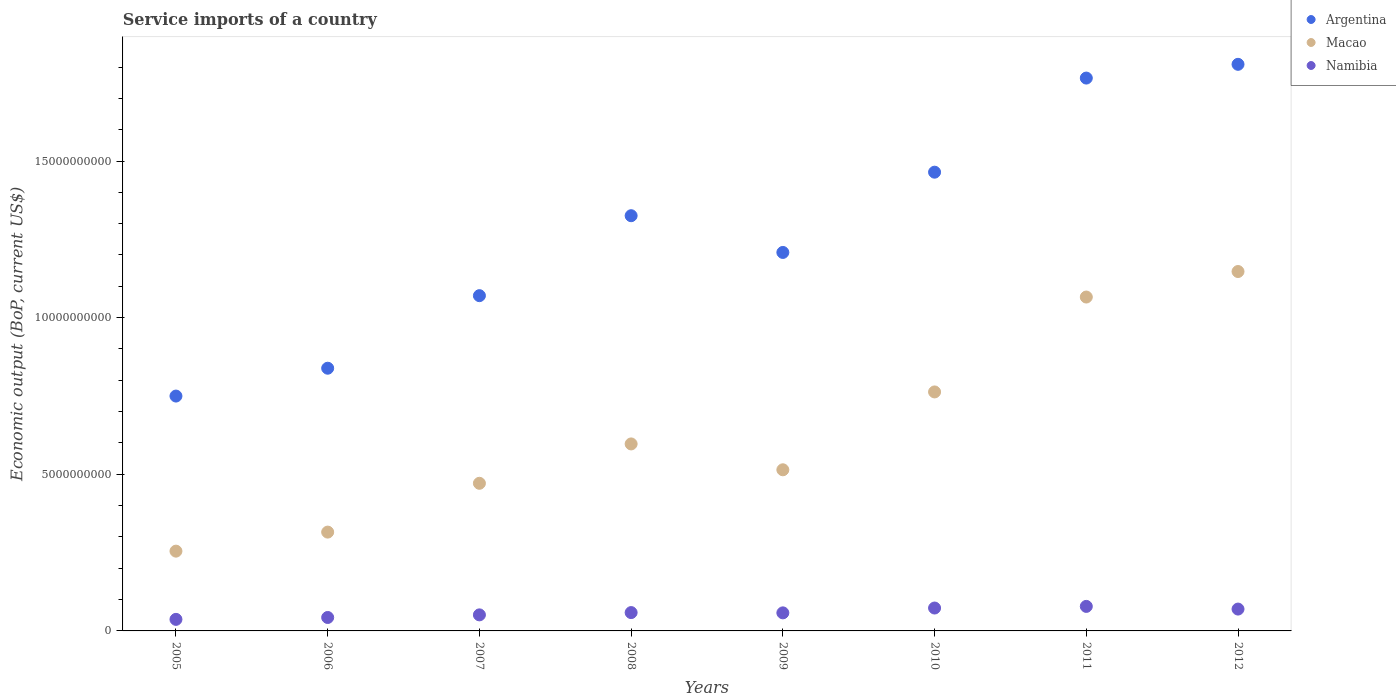Is the number of dotlines equal to the number of legend labels?
Your answer should be very brief. Yes. What is the service imports in Argentina in 2011?
Your response must be concise. 1.76e+1. Across all years, what is the maximum service imports in Argentina?
Your answer should be very brief. 1.81e+1. Across all years, what is the minimum service imports in Namibia?
Provide a short and direct response. 3.69e+08. What is the total service imports in Macao in the graph?
Ensure brevity in your answer.  5.13e+1. What is the difference between the service imports in Macao in 2009 and that in 2010?
Offer a very short reply. -2.49e+09. What is the difference between the service imports in Namibia in 2012 and the service imports in Macao in 2009?
Make the answer very short. -4.45e+09. What is the average service imports in Macao per year?
Offer a terse response. 6.41e+09. In the year 2010, what is the difference between the service imports in Argentina and service imports in Macao?
Your answer should be very brief. 7.01e+09. In how many years, is the service imports in Macao greater than 17000000000 US$?
Your answer should be very brief. 0. What is the ratio of the service imports in Namibia in 2011 to that in 2012?
Your answer should be very brief. 1.12. Is the difference between the service imports in Argentina in 2005 and 2008 greater than the difference between the service imports in Macao in 2005 and 2008?
Your answer should be very brief. No. What is the difference between the highest and the second highest service imports in Argentina?
Provide a succinct answer. 4.39e+08. What is the difference between the highest and the lowest service imports in Argentina?
Your response must be concise. 1.06e+1. Does the service imports in Macao monotonically increase over the years?
Make the answer very short. No. Is the service imports in Macao strictly less than the service imports in Namibia over the years?
Your answer should be compact. No. How many dotlines are there?
Keep it short and to the point. 3. How many years are there in the graph?
Provide a succinct answer. 8. What is the difference between two consecutive major ticks on the Y-axis?
Your answer should be very brief. 5.00e+09. Are the values on the major ticks of Y-axis written in scientific E-notation?
Offer a very short reply. No. Does the graph contain any zero values?
Make the answer very short. No. What is the title of the graph?
Provide a short and direct response. Service imports of a country. What is the label or title of the Y-axis?
Ensure brevity in your answer.  Economic output (BoP, current US$). What is the Economic output (BoP, current US$) of Argentina in 2005?
Your response must be concise. 7.50e+09. What is the Economic output (BoP, current US$) in Macao in 2005?
Ensure brevity in your answer.  2.55e+09. What is the Economic output (BoP, current US$) of Namibia in 2005?
Provide a succinct answer. 3.69e+08. What is the Economic output (BoP, current US$) in Argentina in 2006?
Give a very brief answer. 8.39e+09. What is the Economic output (BoP, current US$) in Macao in 2006?
Provide a succinct answer. 3.15e+09. What is the Economic output (BoP, current US$) of Namibia in 2006?
Make the answer very short. 4.29e+08. What is the Economic output (BoP, current US$) of Argentina in 2007?
Offer a very short reply. 1.07e+1. What is the Economic output (BoP, current US$) in Macao in 2007?
Provide a succinct answer. 4.71e+09. What is the Economic output (BoP, current US$) in Namibia in 2007?
Provide a succinct answer. 5.12e+08. What is the Economic output (BoP, current US$) of Argentina in 2008?
Your answer should be very brief. 1.33e+1. What is the Economic output (BoP, current US$) in Macao in 2008?
Your response must be concise. 5.97e+09. What is the Economic output (BoP, current US$) of Namibia in 2008?
Give a very brief answer. 5.85e+08. What is the Economic output (BoP, current US$) in Argentina in 2009?
Ensure brevity in your answer.  1.21e+1. What is the Economic output (BoP, current US$) in Macao in 2009?
Make the answer very short. 5.14e+09. What is the Economic output (BoP, current US$) of Namibia in 2009?
Your answer should be compact. 5.76e+08. What is the Economic output (BoP, current US$) of Argentina in 2010?
Your response must be concise. 1.46e+1. What is the Economic output (BoP, current US$) in Macao in 2010?
Your response must be concise. 7.63e+09. What is the Economic output (BoP, current US$) of Namibia in 2010?
Offer a terse response. 7.31e+08. What is the Economic output (BoP, current US$) of Argentina in 2011?
Your answer should be compact. 1.76e+1. What is the Economic output (BoP, current US$) of Macao in 2011?
Your response must be concise. 1.07e+1. What is the Economic output (BoP, current US$) of Namibia in 2011?
Give a very brief answer. 7.83e+08. What is the Economic output (BoP, current US$) of Argentina in 2012?
Offer a terse response. 1.81e+1. What is the Economic output (BoP, current US$) in Macao in 2012?
Keep it short and to the point. 1.15e+1. What is the Economic output (BoP, current US$) of Namibia in 2012?
Offer a terse response. 6.97e+08. Across all years, what is the maximum Economic output (BoP, current US$) in Argentina?
Provide a succinct answer. 1.81e+1. Across all years, what is the maximum Economic output (BoP, current US$) of Macao?
Your answer should be compact. 1.15e+1. Across all years, what is the maximum Economic output (BoP, current US$) of Namibia?
Offer a very short reply. 7.83e+08. Across all years, what is the minimum Economic output (BoP, current US$) of Argentina?
Your response must be concise. 7.50e+09. Across all years, what is the minimum Economic output (BoP, current US$) of Macao?
Your answer should be compact. 2.55e+09. Across all years, what is the minimum Economic output (BoP, current US$) in Namibia?
Your answer should be very brief. 3.69e+08. What is the total Economic output (BoP, current US$) in Argentina in the graph?
Make the answer very short. 1.02e+11. What is the total Economic output (BoP, current US$) of Macao in the graph?
Make the answer very short. 5.13e+1. What is the total Economic output (BoP, current US$) in Namibia in the graph?
Provide a short and direct response. 4.68e+09. What is the difference between the Economic output (BoP, current US$) in Argentina in 2005 and that in 2006?
Ensure brevity in your answer.  -8.89e+08. What is the difference between the Economic output (BoP, current US$) in Macao in 2005 and that in 2006?
Give a very brief answer. -6.08e+08. What is the difference between the Economic output (BoP, current US$) of Namibia in 2005 and that in 2006?
Provide a short and direct response. -6.02e+07. What is the difference between the Economic output (BoP, current US$) in Argentina in 2005 and that in 2007?
Your answer should be very brief. -3.20e+09. What is the difference between the Economic output (BoP, current US$) in Macao in 2005 and that in 2007?
Make the answer very short. -2.17e+09. What is the difference between the Economic output (BoP, current US$) in Namibia in 2005 and that in 2007?
Provide a succinct answer. -1.44e+08. What is the difference between the Economic output (BoP, current US$) of Argentina in 2005 and that in 2008?
Make the answer very short. -5.76e+09. What is the difference between the Economic output (BoP, current US$) of Macao in 2005 and that in 2008?
Offer a very short reply. -3.42e+09. What is the difference between the Economic output (BoP, current US$) of Namibia in 2005 and that in 2008?
Your answer should be very brief. -2.17e+08. What is the difference between the Economic output (BoP, current US$) in Argentina in 2005 and that in 2009?
Your answer should be compact. -4.58e+09. What is the difference between the Economic output (BoP, current US$) in Macao in 2005 and that in 2009?
Your response must be concise. -2.60e+09. What is the difference between the Economic output (BoP, current US$) in Namibia in 2005 and that in 2009?
Provide a succinct answer. -2.08e+08. What is the difference between the Economic output (BoP, current US$) in Argentina in 2005 and that in 2010?
Offer a terse response. -7.15e+09. What is the difference between the Economic output (BoP, current US$) of Macao in 2005 and that in 2010?
Your answer should be very brief. -5.08e+09. What is the difference between the Economic output (BoP, current US$) in Namibia in 2005 and that in 2010?
Ensure brevity in your answer.  -3.62e+08. What is the difference between the Economic output (BoP, current US$) of Argentina in 2005 and that in 2011?
Ensure brevity in your answer.  -1.02e+1. What is the difference between the Economic output (BoP, current US$) of Macao in 2005 and that in 2011?
Ensure brevity in your answer.  -8.11e+09. What is the difference between the Economic output (BoP, current US$) in Namibia in 2005 and that in 2011?
Make the answer very short. -4.14e+08. What is the difference between the Economic output (BoP, current US$) of Argentina in 2005 and that in 2012?
Ensure brevity in your answer.  -1.06e+1. What is the difference between the Economic output (BoP, current US$) of Macao in 2005 and that in 2012?
Keep it short and to the point. -8.93e+09. What is the difference between the Economic output (BoP, current US$) in Namibia in 2005 and that in 2012?
Make the answer very short. -3.28e+08. What is the difference between the Economic output (BoP, current US$) of Argentina in 2006 and that in 2007?
Keep it short and to the point. -2.32e+09. What is the difference between the Economic output (BoP, current US$) in Macao in 2006 and that in 2007?
Ensure brevity in your answer.  -1.56e+09. What is the difference between the Economic output (BoP, current US$) in Namibia in 2006 and that in 2007?
Provide a short and direct response. -8.34e+07. What is the difference between the Economic output (BoP, current US$) in Argentina in 2006 and that in 2008?
Offer a very short reply. -4.87e+09. What is the difference between the Economic output (BoP, current US$) in Macao in 2006 and that in 2008?
Give a very brief answer. -2.81e+09. What is the difference between the Economic output (BoP, current US$) of Namibia in 2006 and that in 2008?
Make the answer very short. -1.56e+08. What is the difference between the Economic output (BoP, current US$) in Argentina in 2006 and that in 2009?
Keep it short and to the point. -3.70e+09. What is the difference between the Economic output (BoP, current US$) in Macao in 2006 and that in 2009?
Offer a very short reply. -1.99e+09. What is the difference between the Economic output (BoP, current US$) in Namibia in 2006 and that in 2009?
Ensure brevity in your answer.  -1.47e+08. What is the difference between the Economic output (BoP, current US$) in Argentina in 2006 and that in 2010?
Keep it short and to the point. -6.26e+09. What is the difference between the Economic output (BoP, current US$) of Macao in 2006 and that in 2010?
Offer a very short reply. -4.47e+09. What is the difference between the Economic output (BoP, current US$) of Namibia in 2006 and that in 2010?
Offer a very short reply. -3.02e+08. What is the difference between the Economic output (BoP, current US$) of Argentina in 2006 and that in 2011?
Your response must be concise. -9.26e+09. What is the difference between the Economic output (BoP, current US$) of Macao in 2006 and that in 2011?
Provide a succinct answer. -7.50e+09. What is the difference between the Economic output (BoP, current US$) of Namibia in 2006 and that in 2011?
Make the answer very short. -3.54e+08. What is the difference between the Economic output (BoP, current US$) in Argentina in 2006 and that in 2012?
Keep it short and to the point. -9.70e+09. What is the difference between the Economic output (BoP, current US$) of Macao in 2006 and that in 2012?
Make the answer very short. -8.32e+09. What is the difference between the Economic output (BoP, current US$) of Namibia in 2006 and that in 2012?
Ensure brevity in your answer.  -2.68e+08. What is the difference between the Economic output (BoP, current US$) of Argentina in 2007 and that in 2008?
Your answer should be compact. -2.55e+09. What is the difference between the Economic output (BoP, current US$) in Macao in 2007 and that in 2008?
Your answer should be compact. -1.26e+09. What is the difference between the Economic output (BoP, current US$) in Namibia in 2007 and that in 2008?
Your answer should be compact. -7.30e+07. What is the difference between the Economic output (BoP, current US$) of Argentina in 2007 and that in 2009?
Your answer should be compact. -1.38e+09. What is the difference between the Economic output (BoP, current US$) of Macao in 2007 and that in 2009?
Ensure brevity in your answer.  -4.31e+08. What is the difference between the Economic output (BoP, current US$) of Namibia in 2007 and that in 2009?
Offer a terse response. -6.41e+07. What is the difference between the Economic output (BoP, current US$) of Argentina in 2007 and that in 2010?
Your response must be concise. -3.94e+09. What is the difference between the Economic output (BoP, current US$) in Macao in 2007 and that in 2010?
Your answer should be compact. -2.92e+09. What is the difference between the Economic output (BoP, current US$) of Namibia in 2007 and that in 2010?
Your response must be concise. -2.18e+08. What is the difference between the Economic output (BoP, current US$) of Argentina in 2007 and that in 2011?
Keep it short and to the point. -6.95e+09. What is the difference between the Economic output (BoP, current US$) of Macao in 2007 and that in 2011?
Keep it short and to the point. -5.95e+09. What is the difference between the Economic output (BoP, current US$) in Namibia in 2007 and that in 2011?
Offer a terse response. -2.71e+08. What is the difference between the Economic output (BoP, current US$) of Argentina in 2007 and that in 2012?
Make the answer very short. -7.38e+09. What is the difference between the Economic output (BoP, current US$) in Macao in 2007 and that in 2012?
Offer a terse response. -6.76e+09. What is the difference between the Economic output (BoP, current US$) in Namibia in 2007 and that in 2012?
Provide a succinct answer. -1.85e+08. What is the difference between the Economic output (BoP, current US$) of Argentina in 2008 and that in 2009?
Offer a very short reply. 1.17e+09. What is the difference between the Economic output (BoP, current US$) in Macao in 2008 and that in 2009?
Your answer should be compact. 8.25e+08. What is the difference between the Economic output (BoP, current US$) of Namibia in 2008 and that in 2009?
Give a very brief answer. 8.86e+06. What is the difference between the Economic output (BoP, current US$) of Argentina in 2008 and that in 2010?
Offer a terse response. -1.39e+09. What is the difference between the Economic output (BoP, current US$) in Macao in 2008 and that in 2010?
Your answer should be compact. -1.66e+09. What is the difference between the Economic output (BoP, current US$) in Namibia in 2008 and that in 2010?
Ensure brevity in your answer.  -1.45e+08. What is the difference between the Economic output (BoP, current US$) in Argentina in 2008 and that in 2011?
Your answer should be compact. -4.39e+09. What is the difference between the Economic output (BoP, current US$) of Macao in 2008 and that in 2011?
Offer a terse response. -4.69e+09. What is the difference between the Economic output (BoP, current US$) in Namibia in 2008 and that in 2011?
Make the answer very short. -1.98e+08. What is the difference between the Economic output (BoP, current US$) in Argentina in 2008 and that in 2012?
Make the answer very short. -4.83e+09. What is the difference between the Economic output (BoP, current US$) of Macao in 2008 and that in 2012?
Provide a short and direct response. -5.50e+09. What is the difference between the Economic output (BoP, current US$) in Namibia in 2008 and that in 2012?
Give a very brief answer. -1.12e+08. What is the difference between the Economic output (BoP, current US$) of Argentina in 2009 and that in 2010?
Give a very brief answer. -2.56e+09. What is the difference between the Economic output (BoP, current US$) of Macao in 2009 and that in 2010?
Provide a short and direct response. -2.49e+09. What is the difference between the Economic output (BoP, current US$) in Namibia in 2009 and that in 2010?
Make the answer very short. -1.54e+08. What is the difference between the Economic output (BoP, current US$) in Argentina in 2009 and that in 2011?
Offer a very short reply. -5.57e+09. What is the difference between the Economic output (BoP, current US$) of Macao in 2009 and that in 2011?
Offer a very short reply. -5.51e+09. What is the difference between the Economic output (BoP, current US$) of Namibia in 2009 and that in 2011?
Your response must be concise. -2.06e+08. What is the difference between the Economic output (BoP, current US$) of Argentina in 2009 and that in 2012?
Your answer should be compact. -6.00e+09. What is the difference between the Economic output (BoP, current US$) of Macao in 2009 and that in 2012?
Ensure brevity in your answer.  -6.33e+09. What is the difference between the Economic output (BoP, current US$) in Namibia in 2009 and that in 2012?
Your response must be concise. -1.21e+08. What is the difference between the Economic output (BoP, current US$) in Argentina in 2010 and that in 2011?
Provide a succinct answer. -3.00e+09. What is the difference between the Economic output (BoP, current US$) in Macao in 2010 and that in 2011?
Give a very brief answer. -3.03e+09. What is the difference between the Economic output (BoP, current US$) of Namibia in 2010 and that in 2011?
Keep it short and to the point. -5.22e+07. What is the difference between the Economic output (BoP, current US$) in Argentina in 2010 and that in 2012?
Ensure brevity in your answer.  -3.44e+09. What is the difference between the Economic output (BoP, current US$) of Macao in 2010 and that in 2012?
Your answer should be very brief. -3.84e+09. What is the difference between the Economic output (BoP, current US$) of Namibia in 2010 and that in 2012?
Ensure brevity in your answer.  3.34e+07. What is the difference between the Economic output (BoP, current US$) of Argentina in 2011 and that in 2012?
Ensure brevity in your answer.  -4.39e+08. What is the difference between the Economic output (BoP, current US$) in Macao in 2011 and that in 2012?
Offer a terse response. -8.15e+08. What is the difference between the Economic output (BoP, current US$) in Namibia in 2011 and that in 2012?
Your answer should be very brief. 8.56e+07. What is the difference between the Economic output (BoP, current US$) in Argentina in 2005 and the Economic output (BoP, current US$) in Macao in 2006?
Make the answer very short. 4.34e+09. What is the difference between the Economic output (BoP, current US$) in Argentina in 2005 and the Economic output (BoP, current US$) in Namibia in 2006?
Give a very brief answer. 7.07e+09. What is the difference between the Economic output (BoP, current US$) in Macao in 2005 and the Economic output (BoP, current US$) in Namibia in 2006?
Provide a succinct answer. 2.12e+09. What is the difference between the Economic output (BoP, current US$) of Argentina in 2005 and the Economic output (BoP, current US$) of Macao in 2007?
Offer a terse response. 2.78e+09. What is the difference between the Economic output (BoP, current US$) in Argentina in 2005 and the Economic output (BoP, current US$) in Namibia in 2007?
Offer a terse response. 6.98e+09. What is the difference between the Economic output (BoP, current US$) in Macao in 2005 and the Economic output (BoP, current US$) in Namibia in 2007?
Provide a succinct answer. 2.03e+09. What is the difference between the Economic output (BoP, current US$) in Argentina in 2005 and the Economic output (BoP, current US$) in Macao in 2008?
Keep it short and to the point. 1.53e+09. What is the difference between the Economic output (BoP, current US$) in Argentina in 2005 and the Economic output (BoP, current US$) in Namibia in 2008?
Your response must be concise. 6.91e+09. What is the difference between the Economic output (BoP, current US$) in Macao in 2005 and the Economic output (BoP, current US$) in Namibia in 2008?
Offer a very short reply. 1.96e+09. What is the difference between the Economic output (BoP, current US$) in Argentina in 2005 and the Economic output (BoP, current US$) in Macao in 2009?
Your answer should be very brief. 2.35e+09. What is the difference between the Economic output (BoP, current US$) in Argentina in 2005 and the Economic output (BoP, current US$) in Namibia in 2009?
Provide a succinct answer. 6.92e+09. What is the difference between the Economic output (BoP, current US$) in Macao in 2005 and the Economic output (BoP, current US$) in Namibia in 2009?
Your response must be concise. 1.97e+09. What is the difference between the Economic output (BoP, current US$) of Argentina in 2005 and the Economic output (BoP, current US$) of Macao in 2010?
Ensure brevity in your answer.  -1.32e+08. What is the difference between the Economic output (BoP, current US$) in Argentina in 2005 and the Economic output (BoP, current US$) in Namibia in 2010?
Offer a very short reply. 6.77e+09. What is the difference between the Economic output (BoP, current US$) in Macao in 2005 and the Economic output (BoP, current US$) in Namibia in 2010?
Keep it short and to the point. 1.82e+09. What is the difference between the Economic output (BoP, current US$) of Argentina in 2005 and the Economic output (BoP, current US$) of Macao in 2011?
Your answer should be compact. -3.16e+09. What is the difference between the Economic output (BoP, current US$) in Argentina in 2005 and the Economic output (BoP, current US$) in Namibia in 2011?
Your answer should be compact. 6.71e+09. What is the difference between the Economic output (BoP, current US$) in Macao in 2005 and the Economic output (BoP, current US$) in Namibia in 2011?
Your answer should be compact. 1.76e+09. What is the difference between the Economic output (BoP, current US$) in Argentina in 2005 and the Economic output (BoP, current US$) in Macao in 2012?
Provide a short and direct response. -3.98e+09. What is the difference between the Economic output (BoP, current US$) of Argentina in 2005 and the Economic output (BoP, current US$) of Namibia in 2012?
Keep it short and to the point. 6.80e+09. What is the difference between the Economic output (BoP, current US$) of Macao in 2005 and the Economic output (BoP, current US$) of Namibia in 2012?
Your answer should be very brief. 1.85e+09. What is the difference between the Economic output (BoP, current US$) in Argentina in 2006 and the Economic output (BoP, current US$) in Macao in 2007?
Provide a short and direct response. 3.67e+09. What is the difference between the Economic output (BoP, current US$) in Argentina in 2006 and the Economic output (BoP, current US$) in Namibia in 2007?
Make the answer very short. 7.87e+09. What is the difference between the Economic output (BoP, current US$) in Macao in 2006 and the Economic output (BoP, current US$) in Namibia in 2007?
Your answer should be very brief. 2.64e+09. What is the difference between the Economic output (BoP, current US$) in Argentina in 2006 and the Economic output (BoP, current US$) in Macao in 2008?
Offer a terse response. 2.42e+09. What is the difference between the Economic output (BoP, current US$) in Argentina in 2006 and the Economic output (BoP, current US$) in Namibia in 2008?
Provide a succinct answer. 7.80e+09. What is the difference between the Economic output (BoP, current US$) of Macao in 2006 and the Economic output (BoP, current US$) of Namibia in 2008?
Provide a short and direct response. 2.57e+09. What is the difference between the Economic output (BoP, current US$) in Argentina in 2006 and the Economic output (BoP, current US$) in Macao in 2009?
Ensure brevity in your answer.  3.24e+09. What is the difference between the Economic output (BoP, current US$) in Argentina in 2006 and the Economic output (BoP, current US$) in Namibia in 2009?
Provide a short and direct response. 7.81e+09. What is the difference between the Economic output (BoP, current US$) in Macao in 2006 and the Economic output (BoP, current US$) in Namibia in 2009?
Offer a terse response. 2.58e+09. What is the difference between the Economic output (BoP, current US$) of Argentina in 2006 and the Economic output (BoP, current US$) of Macao in 2010?
Provide a succinct answer. 7.57e+08. What is the difference between the Economic output (BoP, current US$) in Argentina in 2006 and the Economic output (BoP, current US$) in Namibia in 2010?
Provide a succinct answer. 7.65e+09. What is the difference between the Economic output (BoP, current US$) in Macao in 2006 and the Economic output (BoP, current US$) in Namibia in 2010?
Your answer should be very brief. 2.42e+09. What is the difference between the Economic output (BoP, current US$) in Argentina in 2006 and the Economic output (BoP, current US$) in Macao in 2011?
Offer a terse response. -2.27e+09. What is the difference between the Economic output (BoP, current US$) of Argentina in 2006 and the Economic output (BoP, current US$) of Namibia in 2011?
Provide a succinct answer. 7.60e+09. What is the difference between the Economic output (BoP, current US$) in Macao in 2006 and the Economic output (BoP, current US$) in Namibia in 2011?
Give a very brief answer. 2.37e+09. What is the difference between the Economic output (BoP, current US$) of Argentina in 2006 and the Economic output (BoP, current US$) of Macao in 2012?
Give a very brief answer. -3.09e+09. What is the difference between the Economic output (BoP, current US$) of Argentina in 2006 and the Economic output (BoP, current US$) of Namibia in 2012?
Offer a terse response. 7.69e+09. What is the difference between the Economic output (BoP, current US$) of Macao in 2006 and the Economic output (BoP, current US$) of Namibia in 2012?
Make the answer very short. 2.46e+09. What is the difference between the Economic output (BoP, current US$) in Argentina in 2007 and the Economic output (BoP, current US$) in Macao in 2008?
Make the answer very short. 4.73e+09. What is the difference between the Economic output (BoP, current US$) of Argentina in 2007 and the Economic output (BoP, current US$) of Namibia in 2008?
Provide a short and direct response. 1.01e+1. What is the difference between the Economic output (BoP, current US$) of Macao in 2007 and the Economic output (BoP, current US$) of Namibia in 2008?
Offer a very short reply. 4.13e+09. What is the difference between the Economic output (BoP, current US$) of Argentina in 2007 and the Economic output (BoP, current US$) of Macao in 2009?
Offer a very short reply. 5.56e+09. What is the difference between the Economic output (BoP, current US$) of Argentina in 2007 and the Economic output (BoP, current US$) of Namibia in 2009?
Provide a short and direct response. 1.01e+1. What is the difference between the Economic output (BoP, current US$) of Macao in 2007 and the Economic output (BoP, current US$) of Namibia in 2009?
Offer a terse response. 4.14e+09. What is the difference between the Economic output (BoP, current US$) of Argentina in 2007 and the Economic output (BoP, current US$) of Macao in 2010?
Keep it short and to the point. 3.07e+09. What is the difference between the Economic output (BoP, current US$) of Argentina in 2007 and the Economic output (BoP, current US$) of Namibia in 2010?
Your answer should be compact. 9.97e+09. What is the difference between the Economic output (BoP, current US$) of Macao in 2007 and the Economic output (BoP, current US$) of Namibia in 2010?
Provide a succinct answer. 3.98e+09. What is the difference between the Economic output (BoP, current US$) of Argentina in 2007 and the Economic output (BoP, current US$) of Macao in 2011?
Ensure brevity in your answer.  4.39e+07. What is the difference between the Economic output (BoP, current US$) of Argentina in 2007 and the Economic output (BoP, current US$) of Namibia in 2011?
Provide a short and direct response. 9.92e+09. What is the difference between the Economic output (BoP, current US$) in Macao in 2007 and the Economic output (BoP, current US$) in Namibia in 2011?
Your answer should be compact. 3.93e+09. What is the difference between the Economic output (BoP, current US$) in Argentina in 2007 and the Economic output (BoP, current US$) in Macao in 2012?
Ensure brevity in your answer.  -7.71e+08. What is the difference between the Economic output (BoP, current US$) in Argentina in 2007 and the Economic output (BoP, current US$) in Namibia in 2012?
Provide a succinct answer. 1.00e+1. What is the difference between the Economic output (BoP, current US$) in Macao in 2007 and the Economic output (BoP, current US$) in Namibia in 2012?
Make the answer very short. 4.02e+09. What is the difference between the Economic output (BoP, current US$) of Argentina in 2008 and the Economic output (BoP, current US$) of Macao in 2009?
Keep it short and to the point. 8.11e+09. What is the difference between the Economic output (BoP, current US$) in Argentina in 2008 and the Economic output (BoP, current US$) in Namibia in 2009?
Provide a short and direct response. 1.27e+1. What is the difference between the Economic output (BoP, current US$) of Macao in 2008 and the Economic output (BoP, current US$) of Namibia in 2009?
Ensure brevity in your answer.  5.39e+09. What is the difference between the Economic output (BoP, current US$) in Argentina in 2008 and the Economic output (BoP, current US$) in Macao in 2010?
Your response must be concise. 5.63e+09. What is the difference between the Economic output (BoP, current US$) in Argentina in 2008 and the Economic output (BoP, current US$) in Namibia in 2010?
Ensure brevity in your answer.  1.25e+1. What is the difference between the Economic output (BoP, current US$) of Macao in 2008 and the Economic output (BoP, current US$) of Namibia in 2010?
Offer a terse response. 5.24e+09. What is the difference between the Economic output (BoP, current US$) of Argentina in 2008 and the Economic output (BoP, current US$) of Macao in 2011?
Offer a terse response. 2.60e+09. What is the difference between the Economic output (BoP, current US$) of Argentina in 2008 and the Economic output (BoP, current US$) of Namibia in 2011?
Keep it short and to the point. 1.25e+1. What is the difference between the Economic output (BoP, current US$) in Macao in 2008 and the Economic output (BoP, current US$) in Namibia in 2011?
Offer a very short reply. 5.19e+09. What is the difference between the Economic output (BoP, current US$) in Argentina in 2008 and the Economic output (BoP, current US$) in Macao in 2012?
Make the answer very short. 1.78e+09. What is the difference between the Economic output (BoP, current US$) in Argentina in 2008 and the Economic output (BoP, current US$) in Namibia in 2012?
Offer a terse response. 1.26e+1. What is the difference between the Economic output (BoP, current US$) of Macao in 2008 and the Economic output (BoP, current US$) of Namibia in 2012?
Make the answer very short. 5.27e+09. What is the difference between the Economic output (BoP, current US$) in Argentina in 2009 and the Economic output (BoP, current US$) in Macao in 2010?
Keep it short and to the point. 4.45e+09. What is the difference between the Economic output (BoP, current US$) in Argentina in 2009 and the Economic output (BoP, current US$) in Namibia in 2010?
Give a very brief answer. 1.14e+1. What is the difference between the Economic output (BoP, current US$) in Macao in 2009 and the Economic output (BoP, current US$) in Namibia in 2010?
Your answer should be compact. 4.41e+09. What is the difference between the Economic output (BoP, current US$) of Argentina in 2009 and the Economic output (BoP, current US$) of Macao in 2011?
Ensure brevity in your answer.  1.42e+09. What is the difference between the Economic output (BoP, current US$) of Argentina in 2009 and the Economic output (BoP, current US$) of Namibia in 2011?
Your response must be concise. 1.13e+1. What is the difference between the Economic output (BoP, current US$) in Macao in 2009 and the Economic output (BoP, current US$) in Namibia in 2011?
Offer a terse response. 4.36e+09. What is the difference between the Economic output (BoP, current US$) in Argentina in 2009 and the Economic output (BoP, current US$) in Macao in 2012?
Keep it short and to the point. 6.09e+08. What is the difference between the Economic output (BoP, current US$) of Argentina in 2009 and the Economic output (BoP, current US$) of Namibia in 2012?
Provide a succinct answer. 1.14e+1. What is the difference between the Economic output (BoP, current US$) of Macao in 2009 and the Economic output (BoP, current US$) of Namibia in 2012?
Offer a terse response. 4.45e+09. What is the difference between the Economic output (BoP, current US$) in Argentina in 2010 and the Economic output (BoP, current US$) in Macao in 2011?
Make the answer very short. 3.99e+09. What is the difference between the Economic output (BoP, current US$) of Argentina in 2010 and the Economic output (BoP, current US$) of Namibia in 2011?
Offer a terse response. 1.39e+1. What is the difference between the Economic output (BoP, current US$) of Macao in 2010 and the Economic output (BoP, current US$) of Namibia in 2011?
Offer a terse response. 6.85e+09. What is the difference between the Economic output (BoP, current US$) in Argentina in 2010 and the Economic output (BoP, current US$) in Macao in 2012?
Provide a succinct answer. 3.17e+09. What is the difference between the Economic output (BoP, current US$) in Argentina in 2010 and the Economic output (BoP, current US$) in Namibia in 2012?
Keep it short and to the point. 1.39e+1. What is the difference between the Economic output (BoP, current US$) in Macao in 2010 and the Economic output (BoP, current US$) in Namibia in 2012?
Provide a succinct answer. 6.93e+09. What is the difference between the Economic output (BoP, current US$) in Argentina in 2011 and the Economic output (BoP, current US$) in Macao in 2012?
Your answer should be compact. 6.18e+09. What is the difference between the Economic output (BoP, current US$) in Argentina in 2011 and the Economic output (BoP, current US$) in Namibia in 2012?
Offer a very short reply. 1.70e+1. What is the difference between the Economic output (BoP, current US$) of Macao in 2011 and the Economic output (BoP, current US$) of Namibia in 2012?
Offer a very short reply. 9.96e+09. What is the average Economic output (BoP, current US$) of Argentina per year?
Your answer should be compact. 1.28e+1. What is the average Economic output (BoP, current US$) of Macao per year?
Give a very brief answer. 6.41e+09. What is the average Economic output (BoP, current US$) of Namibia per year?
Your answer should be very brief. 5.85e+08. In the year 2005, what is the difference between the Economic output (BoP, current US$) in Argentina and Economic output (BoP, current US$) in Macao?
Your answer should be compact. 4.95e+09. In the year 2005, what is the difference between the Economic output (BoP, current US$) in Argentina and Economic output (BoP, current US$) in Namibia?
Provide a succinct answer. 7.13e+09. In the year 2005, what is the difference between the Economic output (BoP, current US$) in Macao and Economic output (BoP, current US$) in Namibia?
Your answer should be compact. 2.18e+09. In the year 2006, what is the difference between the Economic output (BoP, current US$) in Argentina and Economic output (BoP, current US$) in Macao?
Provide a short and direct response. 5.23e+09. In the year 2006, what is the difference between the Economic output (BoP, current US$) of Argentina and Economic output (BoP, current US$) of Namibia?
Provide a succinct answer. 7.96e+09. In the year 2006, what is the difference between the Economic output (BoP, current US$) of Macao and Economic output (BoP, current US$) of Namibia?
Provide a short and direct response. 2.73e+09. In the year 2007, what is the difference between the Economic output (BoP, current US$) in Argentina and Economic output (BoP, current US$) in Macao?
Provide a succinct answer. 5.99e+09. In the year 2007, what is the difference between the Economic output (BoP, current US$) in Argentina and Economic output (BoP, current US$) in Namibia?
Your answer should be compact. 1.02e+1. In the year 2007, what is the difference between the Economic output (BoP, current US$) in Macao and Economic output (BoP, current US$) in Namibia?
Keep it short and to the point. 4.20e+09. In the year 2008, what is the difference between the Economic output (BoP, current US$) in Argentina and Economic output (BoP, current US$) in Macao?
Offer a terse response. 7.28e+09. In the year 2008, what is the difference between the Economic output (BoP, current US$) of Argentina and Economic output (BoP, current US$) of Namibia?
Offer a very short reply. 1.27e+1. In the year 2008, what is the difference between the Economic output (BoP, current US$) of Macao and Economic output (BoP, current US$) of Namibia?
Give a very brief answer. 5.38e+09. In the year 2009, what is the difference between the Economic output (BoP, current US$) of Argentina and Economic output (BoP, current US$) of Macao?
Give a very brief answer. 6.94e+09. In the year 2009, what is the difference between the Economic output (BoP, current US$) of Argentina and Economic output (BoP, current US$) of Namibia?
Give a very brief answer. 1.15e+1. In the year 2009, what is the difference between the Economic output (BoP, current US$) of Macao and Economic output (BoP, current US$) of Namibia?
Your answer should be very brief. 4.57e+09. In the year 2010, what is the difference between the Economic output (BoP, current US$) of Argentina and Economic output (BoP, current US$) of Macao?
Your answer should be very brief. 7.01e+09. In the year 2010, what is the difference between the Economic output (BoP, current US$) in Argentina and Economic output (BoP, current US$) in Namibia?
Provide a short and direct response. 1.39e+1. In the year 2010, what is the difference between the Economic output (BoP, current US$) of Macao and Economic output (BoP, current US$) of Namibia?
Offer a very short reply. 6.90e+09. In the year 2011, what is the difference between the Economic output (BoP, current US$) in Argentina and Economic output (BoP, current US$) in Macao?
Your response must be concise. 6.99e+09. In the year 2011, what is the difference between the Economic output (BoP, current US$) in Argentina and Economic output (BoP, current US$) in Namibia?
Give a very brief answer. 1.69e+1. In the year 2011, what is the difference between the Economic output (BoP, current US$) of Macao and Economic output (BoP, current US$) of Namibia?
Offer a terse response. 9.87e+09. In the year 2012, what is the difference between the Economic output (BoP, current US$) of Argentina and Economic output (BoP, current US$) of Macao?
Offer a terse response. 6.61e+09. In the year 2012, what is the difference between the Economic output (BoP, current US$) in Argentina and Economic output (BoP, current US$) in Namibia?
Offer a very short reply. 1.74e+1. In the year 2012, what is the difference between the Economic output (BoP, current US$) in Macao and Economic output (BoP, current US$) in Namibia?
Provide a short and direct response. 1.08e+1. What is the ratio of the Economic output (BoP, current US$) of Argentina in 2005 to that in 2006?
Your answer should be very brief. 0.89. What is the ratio of the Economic output (BoP, current US$) in Macao in 2005 to that in 2006?
Ensure brevity in your answer.  0.81. What is the ratio of the Economic output (BoP, current US$) in Namibia in 2005 to that in 2006?
Offer a very short reply. 0.86. What is the ratio of the Economic output (BoP, current US$) in Argentina in 2005 to that in 2007?
Your answer should be compact. 0.7. What is the ratio of the Economic output (BoP, current US$) of Macao in 2005 to that in 2007?
Offer a terse response. 0.54. What is the ratio of the Economic output (BoP, current US$) in Namibia in 2005 to that in 2007?
Keep it short and to the point. 0.72. What is the ratio of the Economic output (BoP, current US$) in Argentina in 2005 to that in 2008?
Your answer should be very brief. 0.57. What is the ratio of the Economic output (BoP, current US$) in Macao in 2005 to that in 2008?
Provide a short and direct response. 0.43. What is the ratio of the Economic output (BoP, current US$) in Namibia in 2005 to that in 2008?
Keep it short and to the point. 0.63. What is the ratio of the Economic output (BoP, current US$) of Argentina in 2005 to that in 2009?
Keep it short and to the point. 0.62. What is the ratio of the Economic output (BoP, current US$) in Macao in 2005 to that in 2009?
Make the answer very short. 0.5. What is the ratio of the Economic output (BoP, current US$) in Namibia in 2005 to that in 2009?
Your answer should be very brief. 0.64. What is the ratio of the Economic output (BoP, current US$) in Argentina in 2005 to that in 2010?
Keep it short and to the point. 0.51. What is the ratio of the Economic output (BoP, current US$) in Macao in 2005 to that in 2010?
Ensure brevity in your answer.  0.33. What is the ratio of the Economic output (BoP, current US$) of Namibia in 2005 to that in 2010?
Give a very brief answer. 0.5. What is the ratio of the Economic output (BoP, current US$) in Argentina in 2005 to that in 2011?
Give a very brief answer. 0.42. What is the ratio of the Economic output (BoP, current US$) in Macao in 2005 to that in 2011?
Offer a very short reply. 0.24. What is the ratio of the Economic output (BoP, current US$) of Namibia in 2005 to that in 2011?
Your answer should be very brief. 0.47. What is the ratio of the Economic output (BoP, current US$) in Argentina in 2005 to that in 2012?
Keep it short and to the point. 0.41. What is the ratio of the Economic output (BoP, current US$) in Macao in 2005 to that in 2012?
Your answer should be compact. 0.22. What is the ratio of the Economic output (BoP, current US$) of Namibia in 2005 to that in 2012?
Give a very brief answer. 0.53. What is the ratio of the Economic output (BoP, current US$) of Argentina in 2006 to that in 2007?
Offer a terse response. 0.78. What is the ratio of the Economic output (BoP, current US$) of Macao in 2006 to that in 2007?
Provide a succinct answer. 0.67. What is the ratio of the Economic output (BoP, current US$) of Namibia in 2006 to that in 2007?
Offer a terse response. 0.84. What is the ratio of the Economic output (BoP, current US$) in Argentina in 2006 to that in 2008?
Give a very brief answer. 0.63. What is the ratio of the Economic output (BoP, current US$) of Macao in 2006 to that in 2008?
Your answer should be very brief. 0.53. What is the ratio of the Economic output (BoP, current US$) in Namibia in 2006 to that in 2008?
Give a very brief answer. 0.73. What is the ratio of the Economic output (BoP, current US$) of Argentina in 2006 to that in 2009?
Provide a short and direct response. 0.69. What is the ratio of the Economic output (BoP, current US$) of Macao in 2006 to that in 2009?
Offer a terse response. 0.61. What is the ratio of the Economic output (BoP, current US$) of Namibia in 2006 to that in 2009?
Provide a succinct answer. 0.74. What is the ratio of the Economic output (BoP, current US$) in Argentina in 2006 to that in 2010?
Provide a short and direct response. 0.57. What is the ratio of the Economic output (BoP, current US$) in Macao in 2006 to that in 2010?
Make the answer very short. 0.41. What is the ratio of the Economic output (BoP, current US$) in Namibia in 2006 to that in 2010?
Offer a terse response. 0.59. What is the ratio of the Economic output (BoP, current US$) in Argentina in 2006 to that in 2011?
Your answer should be very brief. 0.48. What is the ratio of the Economic output (BoP, current US$) in Macao in 2006 to that in 2011?
Provide a short and direct response. 0.3. What is the ratio of the Economic output (BoP, current US$) in Namibia in 2006 to that in 2011?
Provide a short and direct response. 0.55. What is the ratio of the Economic output (BoP, current US$) of Argentina in 2006 to that in 2012?
Offer a very short reply. 0.46. What is the ratio of the Economic output (BoP, current US$) in Macao in 2006 to that in 2012?
Offer a terse response. 0.28. What is the ratio of the Economic output (BoP, current US$) in Namibia in 2006 to that in 2012?
Provide a short and direct response. 0.62. What is the ratio of the Economic output (BoP, current US$) of Argentina in 2007 to that in 2008?
Ensure brevity in your answer.  0.81. What is the ratio of the Economic output (BoP, current US$) in Macao in 2007 to that in 2008?
Keep it short and to the point. 0.79. What is the ratio of the Economic output (BoP, current US$) of Namibia in 2007 to that in 2008?
Keep it short and to the point. 0.88. What is the ratio of the Economic output (BoP, current US$) of Argentina in 2007 to that in 2009?
Your answer should be compact. 0.89. What is the ratio of the Economic output (BoP, current US$) of Macao in 2007 to that in 2009?
Keep it short and to the point. 0.92. What is the ratio of the Economic output (BoP, current US$) in Namibia in 2007 to that in 2009?
Provide a succinct answer. 0.89. What is the ratio of the Economic output (BoP, current US$) of Argentina in 2007 to that in 2010?
Your answer should be very brief. 0.73. What is the ratio of the Economic output (BoP, current US$) of Macao in 2007 to that in 2010?
Make the answer very short. 0.62. What is the ratio of the Economic output (BoP, current US$) of Namibia in 2007 to that in 2010?
Ensure brevity in your answer.  0.7. What is the ratio of the Economic output (BoP, current US$) of Argentina in 2007 to that in 2011?
Your answer should be compact. 0.61. What is the ratio of the Economic output (BoP, current US$) of Macao in 2007 to that in 2011?
Your answer should be compact. 0.44. What is the ratio of the Economic output (BoP, current US$) of Namibia in 2007 to that in 2011?
Ensure brevity in your answer.  0.65. What is the ratio of the Economic output (BoP, current US$) in Argentina in 2007 to that in 2012?
Provide a succinct answer. 0.59. What is the ratio of the Economic output (BoP, current US$) in Macao in 2007 to that in 2012?
Provide a short and direct response. 0.41. What is the ratio of the Economic output (BoP, current US$) of Namibia in 2007 to that in 2012?
Offer a terse response. 0.73. What is the ratio of the Economic output (BoP, current US$) of Argentina in 2008 to that in 2009?
Give a very brief answer. 1.1. What is the ratio of the Economic output (BoP, current US$) in Macao in 2008 to that in 2009?
Ensure brevity in your answer.  1.16. What is the ratio of the Economic output (BoP, current US$) in Namibia in 2008 to that in 2009?
Your answer should be very brief. 1.02. What is the ratio of the Economic output (BoP, current US$) in Argentina in 2008 to that in 2010?
Your answer should be compact. 0.91. What is the ratio of the Economic output (BoP, current US$) in Macao in 2008 to that in 2010?
Ensure brevity in your answer.  0.78. What is the ratio of the Economic output (BoP, current US$) in Namibia in 2008 to that in 2010?
Offer a terse response. 0.8. What is the ratio of the Economic output (BoP, current US$) in Argentina in 2008 to that in 2011?
Ensure brevity in your answer.  0.75. What is the ratio of the Economic output (BoP, current US$) of Macao in 2008 to that in 2011?
Provide a succinct answer. 0.56. What is the ratio of the Economic output (BoP, current US$) in Namibia in 2008 to that in 2011?
Ensure brevity in your answer.  0.75. What is the ratio of the Economic output (BoP, current US$) of Argentina in 2008 to that in 2012?
Your answer should be very brief. 0.73. What is the ratio of the Economic output (BoP, current US$) of Macao in 2008 to that in 2012?
Ensure brevity in your answer.  0.52. What is the ratio of the Economic output (BoP, current US$) of Namibia in 2008 to that in 2012?
Make the answer very short. 0.84. What is the ratio of the Economic output (BoP, current US$) in Argentina in 2009 to that in 2010?
Make the answer very short. 0.82. What is the ratio of the Economic output (BoP, current US$) of Macao in 2009 to that in 2010?
Offer a very short reply. 0.67. What is the ratio of the Economic output (BoP, current US$) of Namibia in 2009 to that in 2010?
Provide a succinct answer. 0.79. What is the ratio of the Economic output (BoP, current US$) of Argentina in 2009 to that in 2011?
Make the answer very short. 0.68. What is the ratio of the Economic output (BoP, current US$) in Macao in 2009 to that in 2011?
Your response must be concise. 0.48. What is the ratio of the Economic output (BoP, current US$) of Namibia in 2009 to that in 2011?
Your response must be concise. 0.74. What is the ratio of the Economic output (BoP, current US$) of Argentina in 2009 to that in 2012?
Provide a short and direct response. 0.67. What is the ratio of the Economic output (BoP, current US$) of Macao in 2009 to that in 2012?
Offer a terse response. 0.45. What is the ratio of the Economic output (BoP, current US$) of Namibia in 2009 to that in 2012?
Provide a short and direct response. 0.83. What is the ratio of the Economic output (BoP, current US$) in Argentina in 2010 to that in 2011?
Provide a succinct answer. 0.83. What is the ratio of the Economic output (BoP, current US$) of Macao in 2010 to that in 2011?
Your answer should be compact. 0.72. What is the ratio of the Economic output (BoP, current US$) of Argentina in 2010 to that in 2012?
Offer a terse response. 0.81. What is the ratio of the Economic output (BoP, current US$) in Macao in 2010 to that in 2012?
Provide a short and direct response. 0.67. What is the ratio of the Economic output (BoP, current US$) in Namibia in 2010 to that in 2012?
Offer a terse response. 1.05. What is the ratio of the Economic output (BoP, current US$) in Argentina in 2011 to that in 2012?
Provide a succinct answer. 0.98. What is the ratio of the Economic output (BoP, current US$) in Macao in 2011 to that in 2012?
Your response must be concise. 0.93. What is the ratio of the Economic output (BoP, current US$) in Namibia in 2011 to that in 2012?
Provide a short and direct response. 1.12. What is the difference between the highest and the second highest Economic output (BoP, current US$) in Argentina?
Your answer should be very brief. 4.39e+08. What is the difference between the highest and the second highest Economic output (BoP, current US$) of Macao?
Give a very brief answer. 8.15e+08. What is the difference between the highest and the second highest Economic output (BoP, current US$) in Namibia?
Keep it short and to the point. 5.22e+07. What is the difference between the highest and the lowest Economic output (BoP, current US$) of Argentina?
Offer a very short reply. 1.06e+1. What is the difference between the highest and the lowest Economic output (BoP, current US$) in Macao?
Provide a short and direct response. 8.93e+09. What is the difference between the highest and the lowest Economic output (BoP, current US$) of Namibia?
Your answer should be very brief. 4.14e+08. 